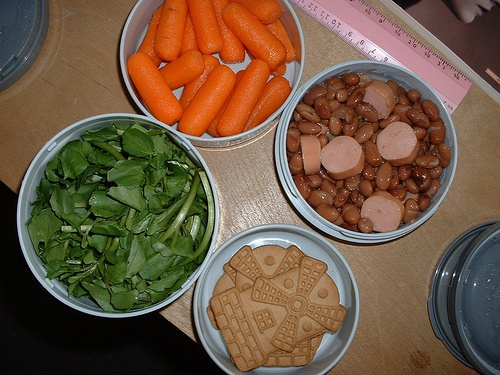Describe the objects in this image and their specific colors. I can see dining table in darkblue, gray, and brown tones, bowl in darkblue, darkgreen, black, and gray tones, bowl in darkblue, maroon, and gray tones, bowl in darkblue, red, brown, and darkgray tones, and bowl in darkblue, gray, darkgray, and tan tones in this image. 